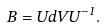Convert formula to latex. <formula><loc_0><loc_0><loc_500><loc_500>B = U d V U ^ { - 1 } .</formula> 